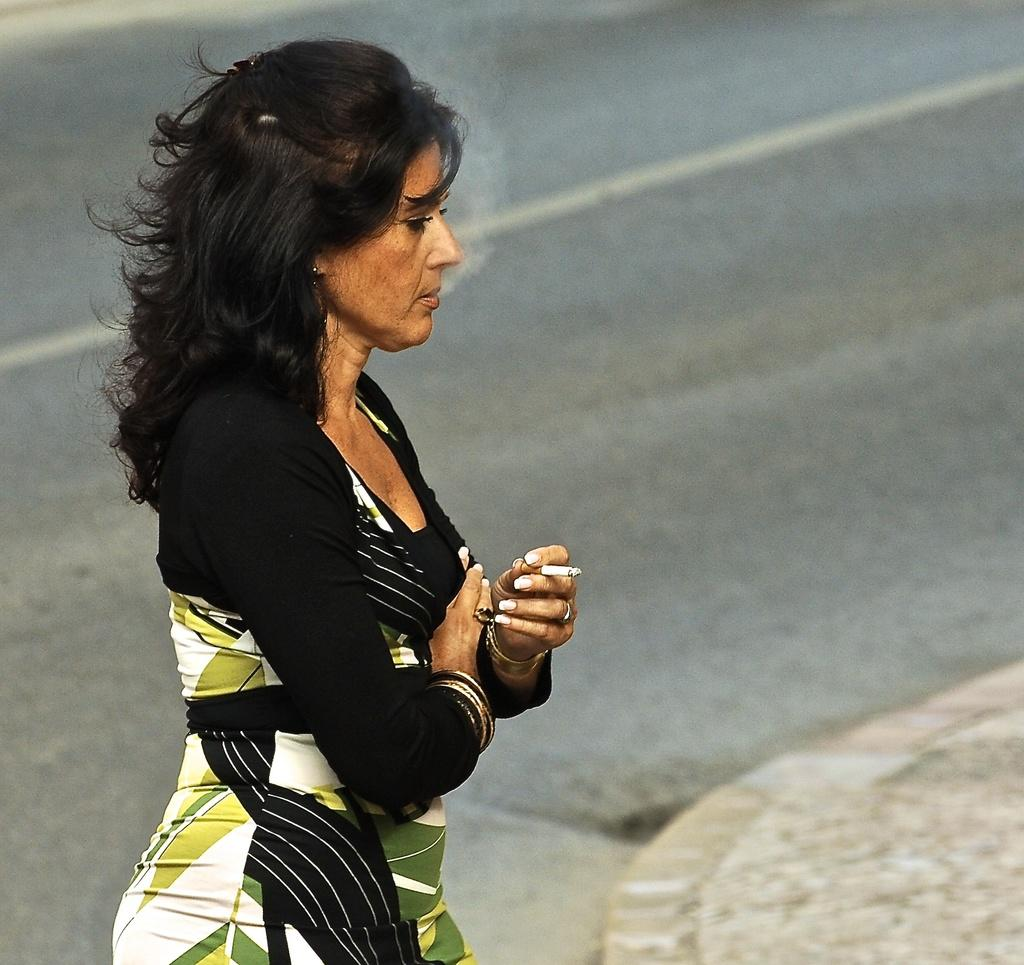Who is present in the image? There is a woman in the image. What is the woman doing in the image? The woman is standing and smoking. What can be seen in the background of the image? There is a road visible in the image. What type of stitch is the woman using to sew a button on her shirt in the image? There is no indication in the image that the woman is sewing a button or using any stitch. 